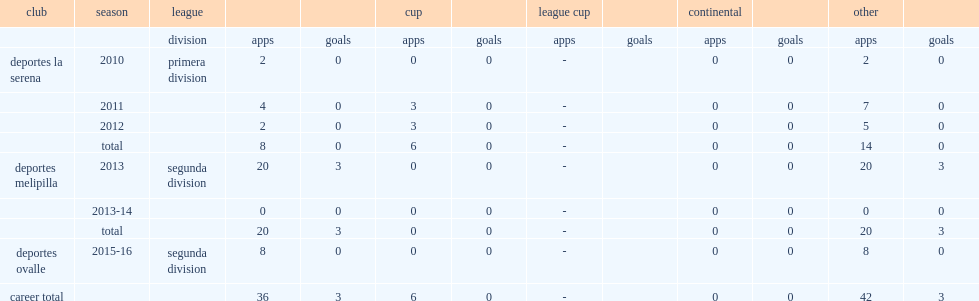In 2013, which league did silva join deportes melipilla? Segunda division. 